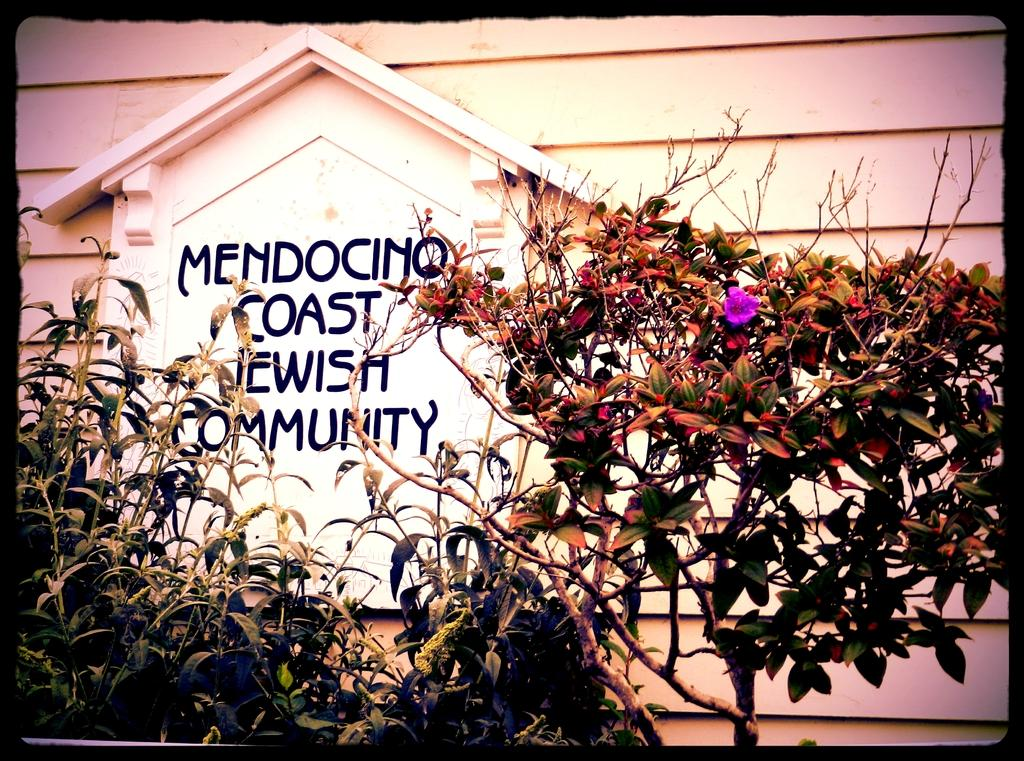What type of living organisms can be seen in the image? Plants can be seen in the image. What color is the background wall in the image? The background wall is white. What is written on the wall in the image? There is text written on the wall in the image. How many girls are involved in the crime depicted in the image? There is no crime or girls depicted in the image; it features plants and a white background wall with text. 